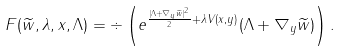Convert formula to latex. <formula><loc_0><loc_0><loc_500><loc_500>F ( \widetilde { w } , \lambda , x , \Lambda ) = \div \left ( e ^ { \frac { | \Lambda + \nabla _ { y } \widetilde { w } | ^ { 2 } } { 2 } + \lambda V ( x , y ) } ( \Lambda + \nabla _ { y } \widetilde { w } ) \right ) .</formula> 